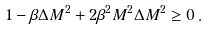<formula> <loc_0><loc_0><loc_500><loc_500>1 - \beta \Delta M ^ { 2 } + 2 \beta ^ { 2 } M ^ { 2 } \Delta M ^ { 2 } \geq 0 \, .</formula> 